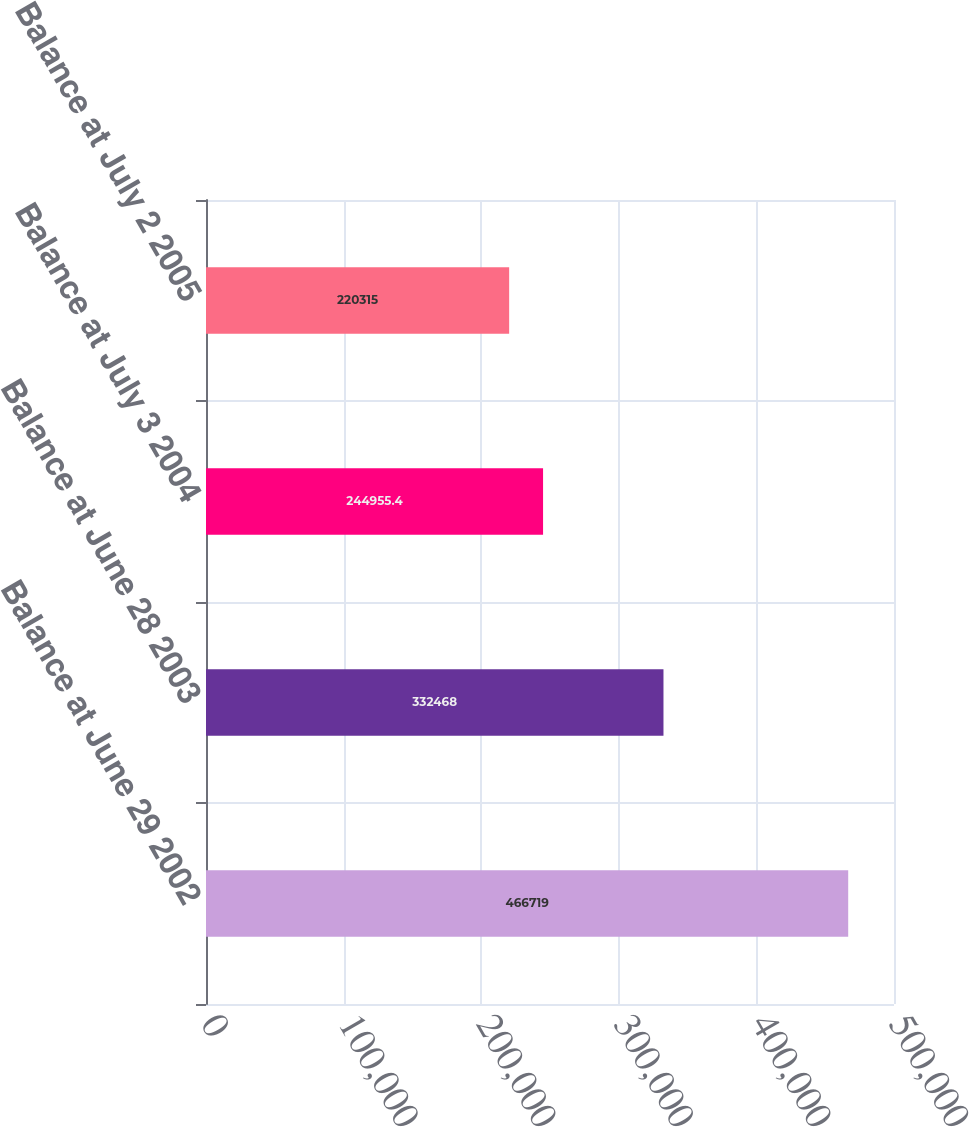<chart> <loc_0><loc_0><loc_500><loc_500><bar_chart><fcel>Balance at June 29 2002<fcel>Balance at June 28 2003<fcel>Balance at July 3 2004<fcel>Balance at July 2 2005<nl><fcel>466719<fcel>332468<fcel>244955<fcel>220315<nl></chart> 